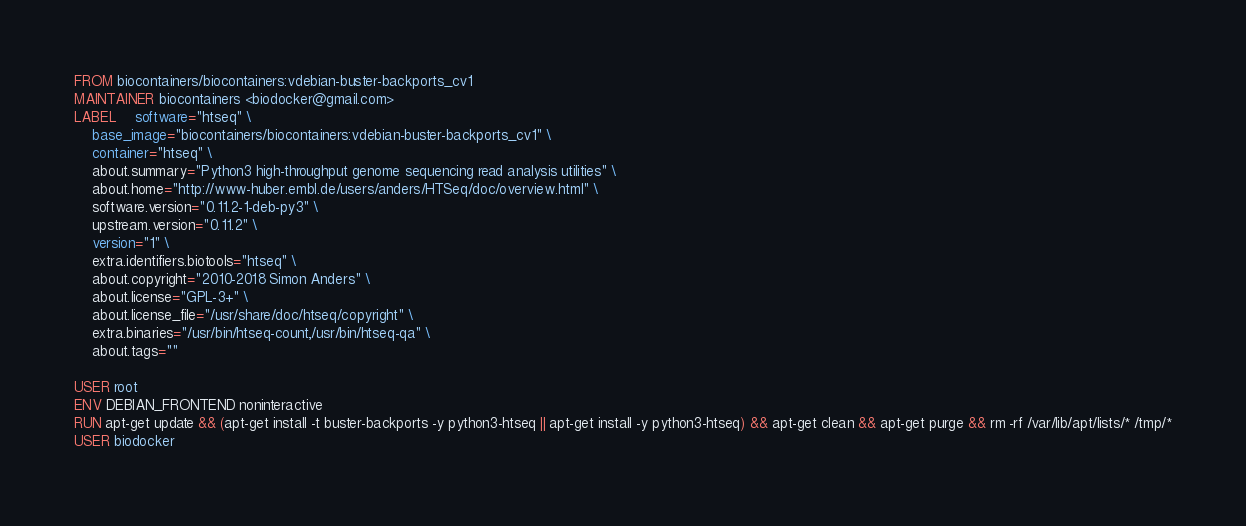Convert code to text. <code><loc_0><loc_0><loc_500><loc_500><_Dockerfile_>FROM biocontainers/biocontainers:vdebian-buster-backports_cv1
MAINTAINER biocontainers <biodocker@gmail.com>
LABEL    software="htseq" \ 
    base_image="biocontainers/biocontainers:vdebian-buster-backports_cv1" \ 
    container="htseq" \ 
    about.summary="Python3 high-throughput genome sequencing read analysis utilities" \ 
    about.home="http://www-huber.embl.de/users/anders/HTSeq/doc/overview.html" \ 
    software.version="0.11.2-1-deb-py3" \ 
    upstream.version="0.11.2" \ 
    version="1" \ 
    extra.identifiers.biotools="htseq" \ 
    about.copyright="2010-2018 Simon Anders" \ 
    about.license="GPL-3+" \ 
    about.license_file="/usr/share/doc/htseq/copyright" \ 
    extra.binaries="/usr/bin/htseq-count,/usr/bin/htseq-qa" \ 
    about.tags=""

USER root
ENV DEBIAN_FRONTEND noninteractive
RUN apt-get update && (apt-get install -t buster-backports -y python3-htseq || apt-get install -y python3-htseq) && apt-get clean && apt-get purge && rm -rf /var/lib/apt/lists/* /tmp/*
USER biodocker
</code> 